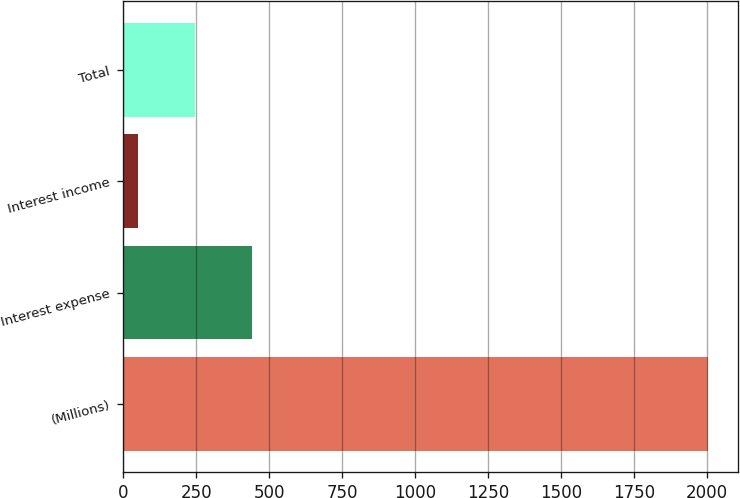<chart> <loc_0><loc_0><loc_500><loc_500><bar_chart><fcel>(Millions)<fcel>Interest expense<fcel>Interest income<fcel>Total<nl><fcel>2006<fcel>442<fcel>51<fcel>246.5<nl></chart> 